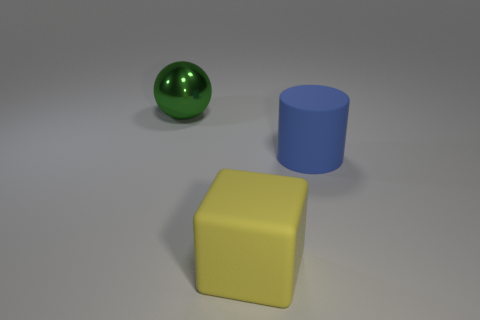Add 2 large green objects. How many objects exist? 5 Subtract all balls. How many objects are left? 2 Add 1 green spheres. How many green spheres are left? 2 Add 3 large green shiny balls. How many large green shiny balls exist? 4 Subtract 1 green balls. How many objects are left? 2 Subtract all brown metallic things. Subtract all big blue matte cylinders. How many objects are left? 2 